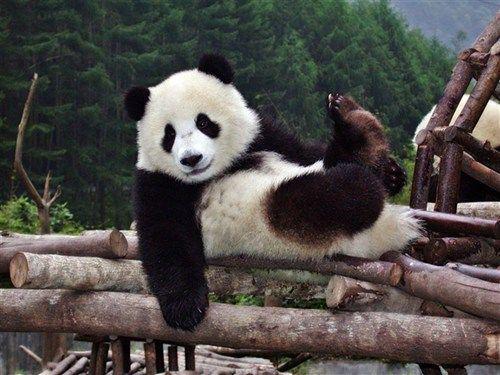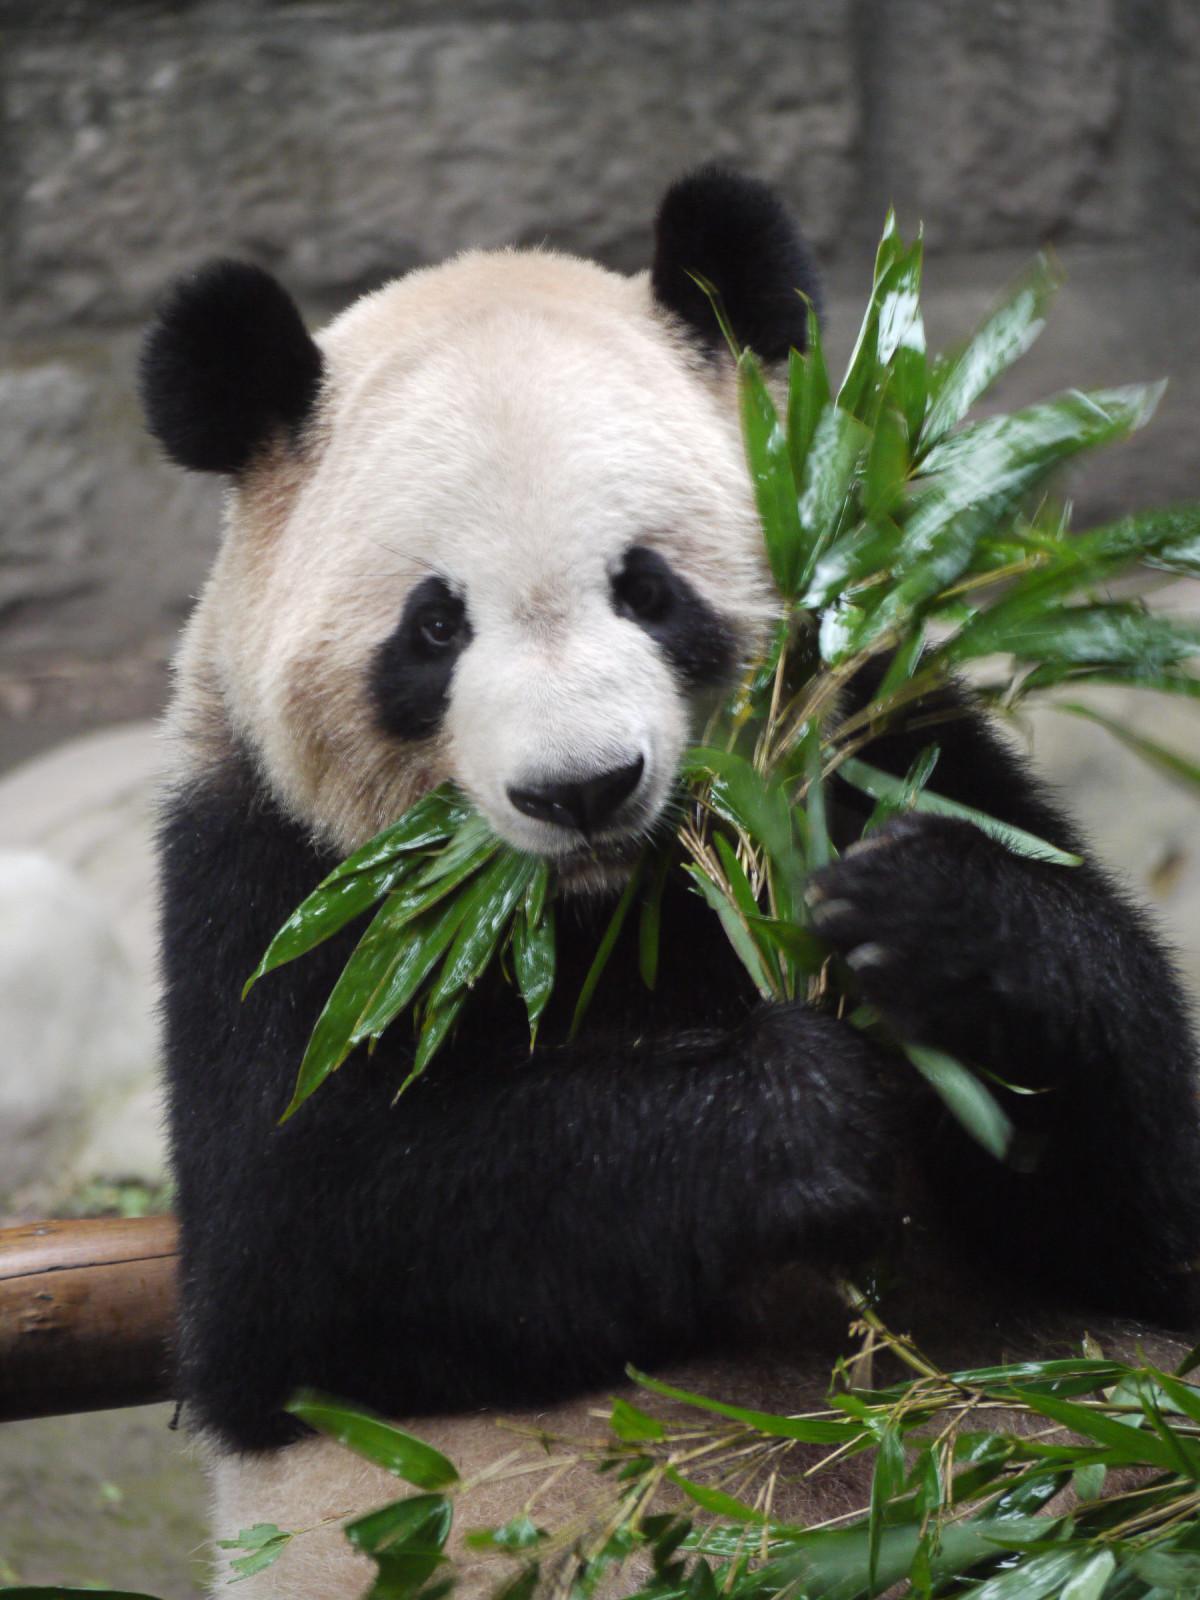The first image is the image on the left, the second image is the image on the right. Evaluate the accuracy of this statement regarding the images: "One of the pandas is eating on bamboo.". Is it true? Answer yes or no. Yes. The first image is the image on the left, the second image is the image on the right. Given the left and right images, does the statement "Only one image shows a panda munching on some type of foliage." hold true? Answer yes or no. Yes. 